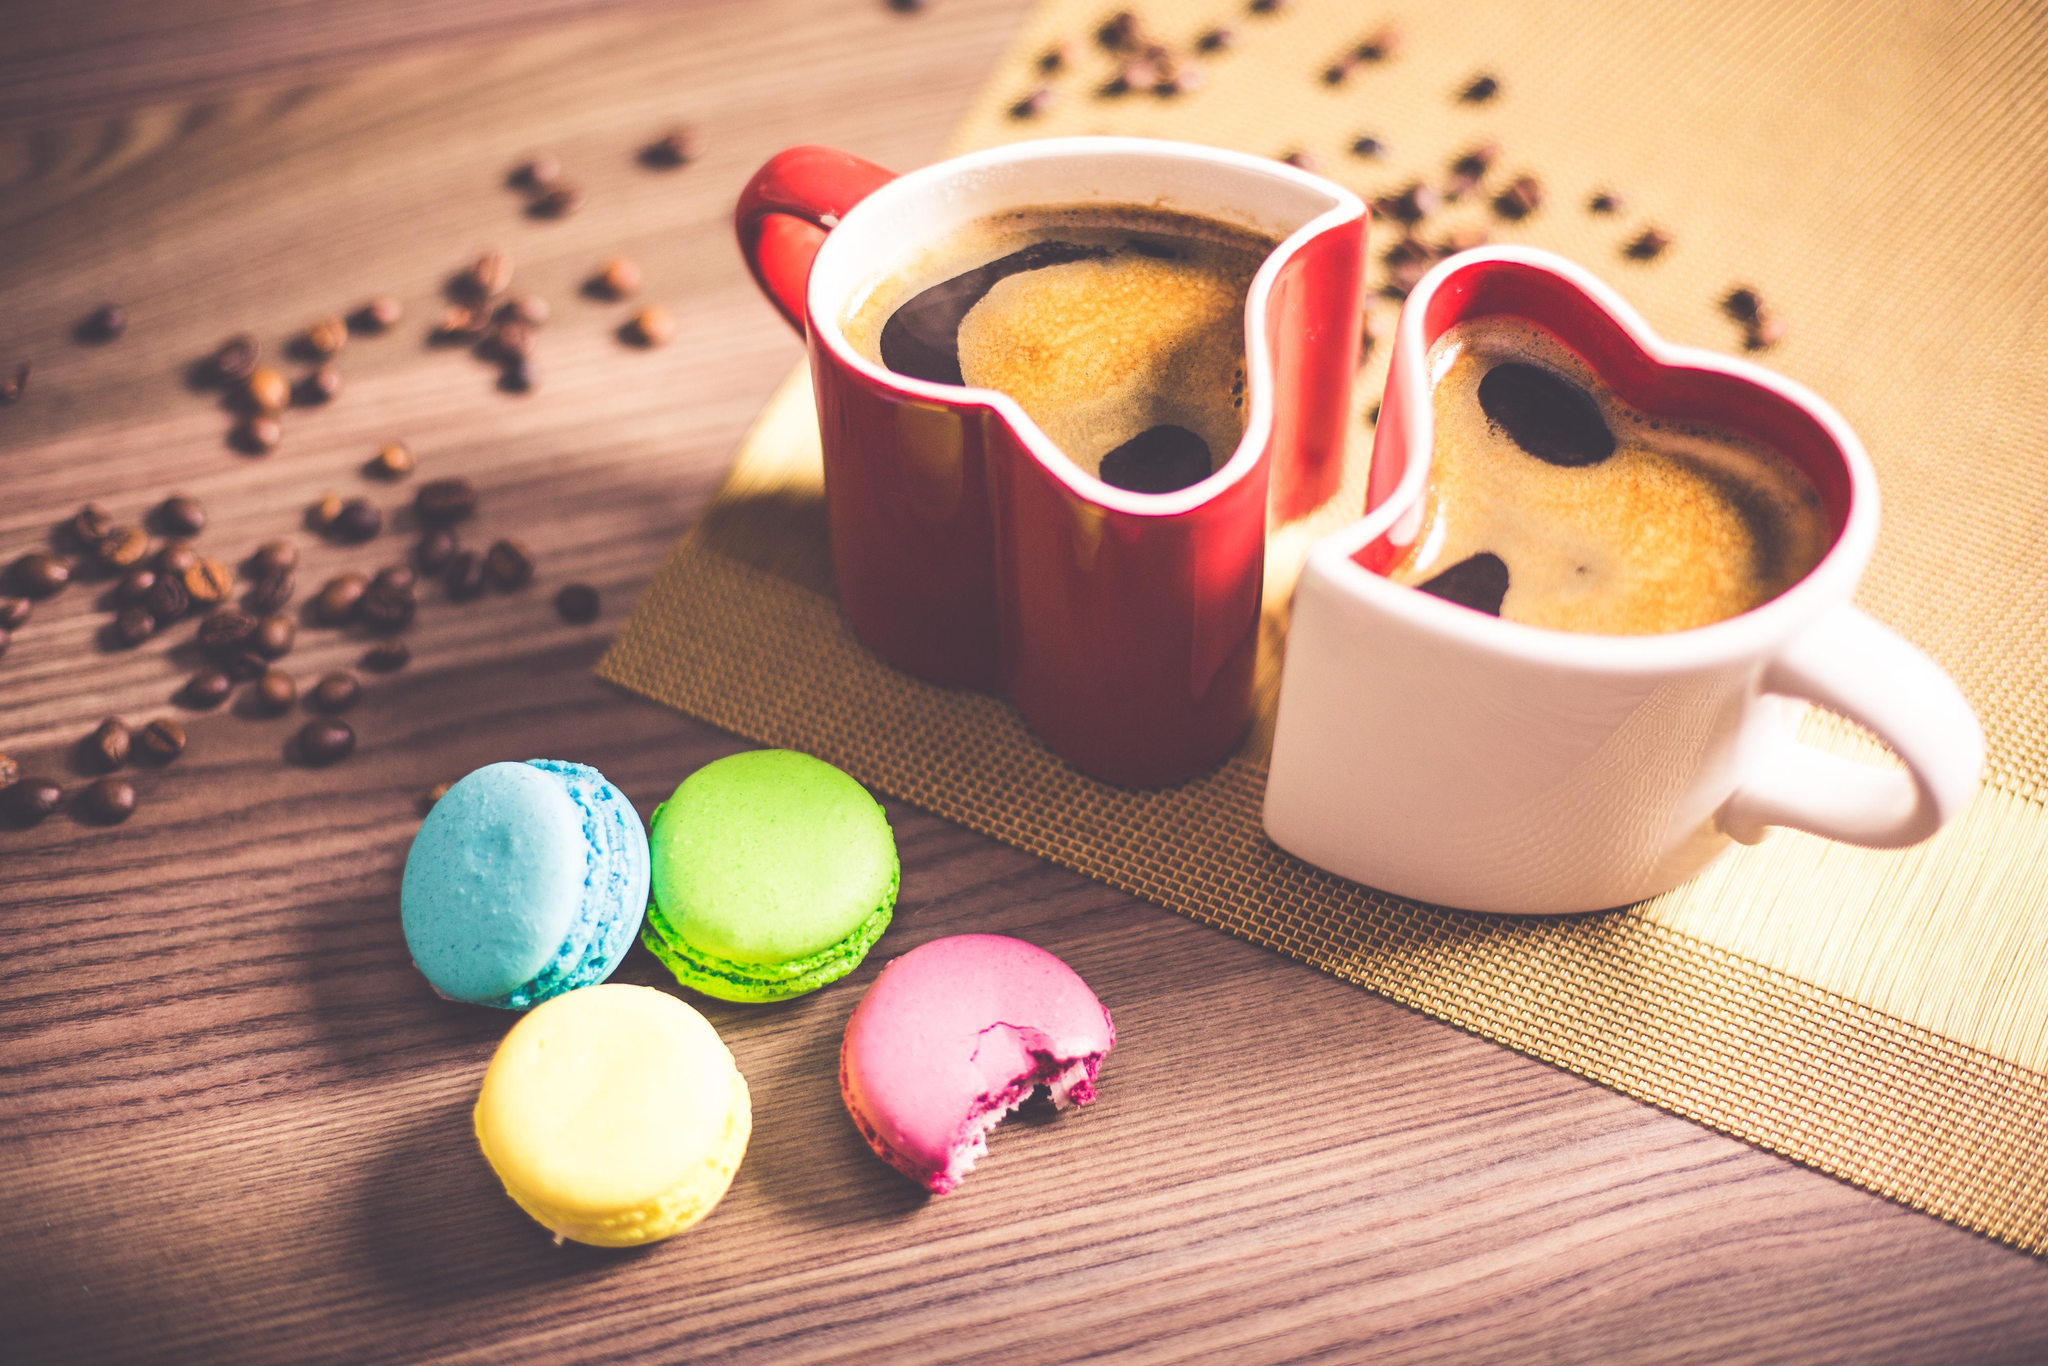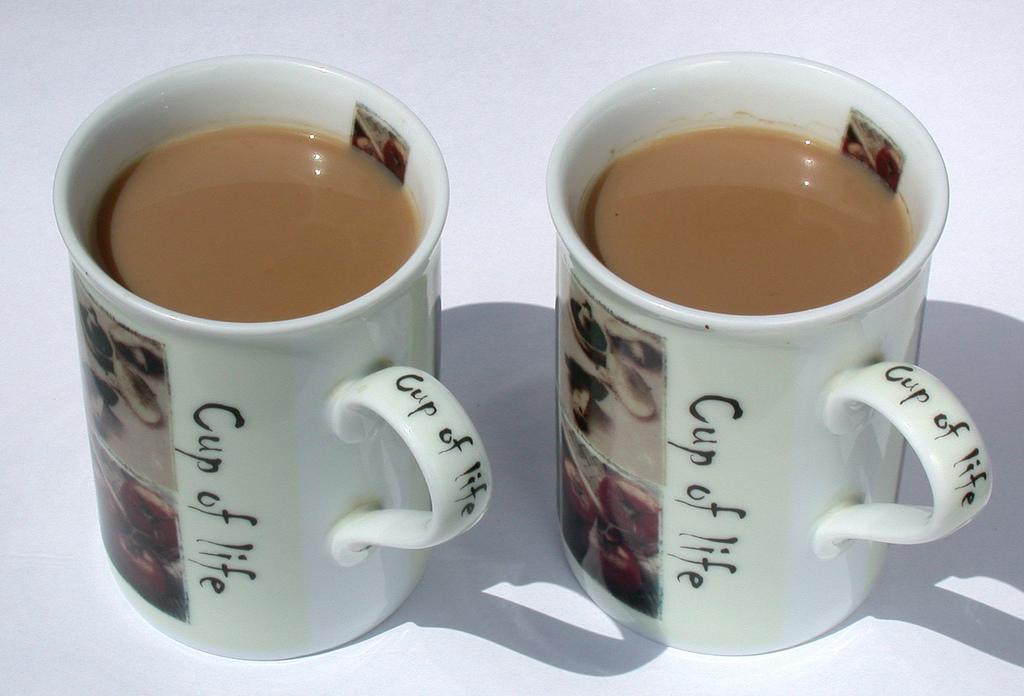The first image is the image on the left, the second image is the image on the right. For the images shown, is this caption "At least one of the images does not contain any brown wood." true? Answer yes or no. Yes. 